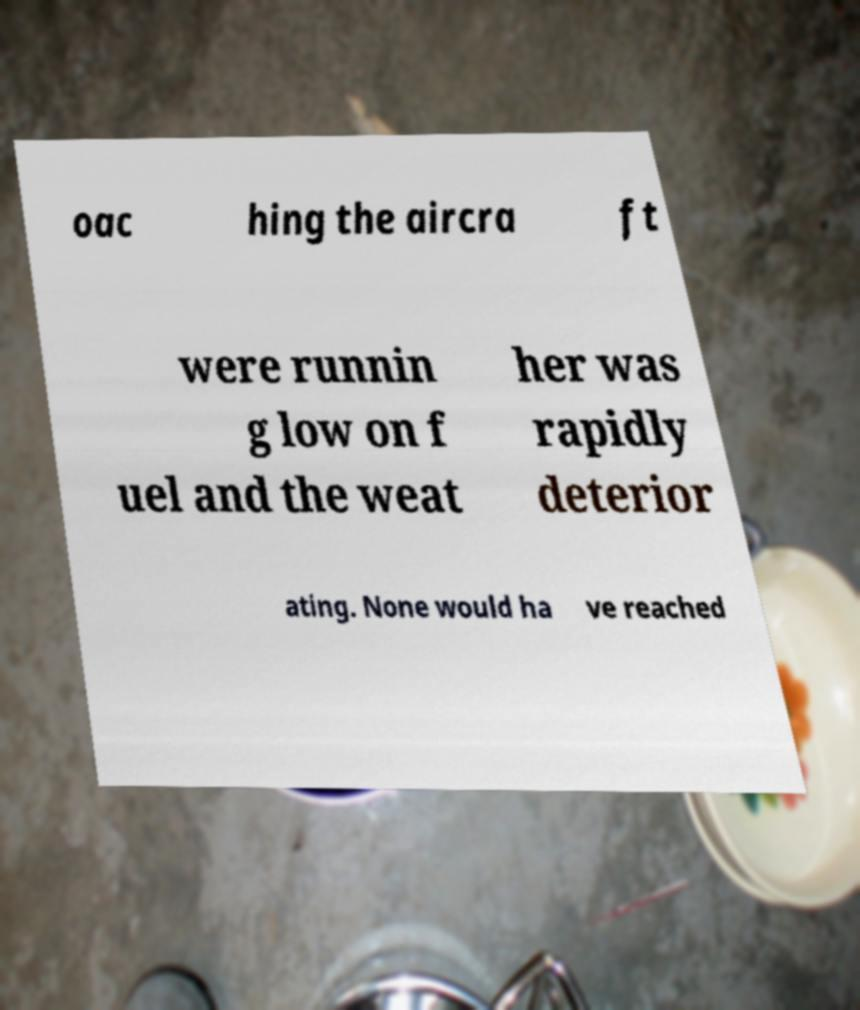For documentation purposes, I need the text within this image transcribed. Could you provide that? oac hing the aircra ft were runnin g low on f uel and the weat her was rapidly deterior ating. None would ha ve reached 